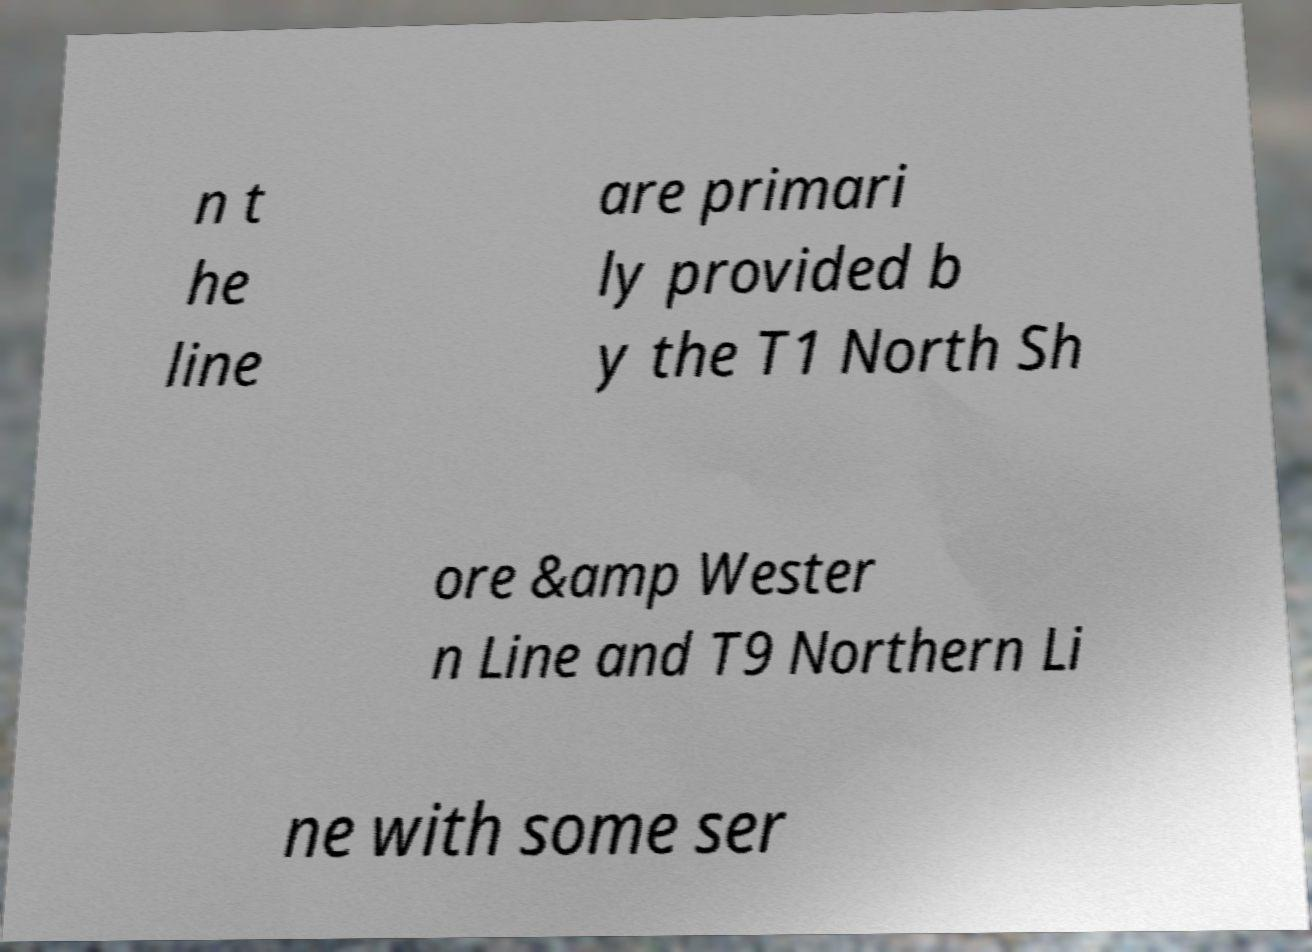Could you assist in decoding the text presented in this image and type it out clearly? n t he line are primari ly provided b y the T1 North Sh ore &amp Wester n Line and T9 Northern Li ne with some ser 